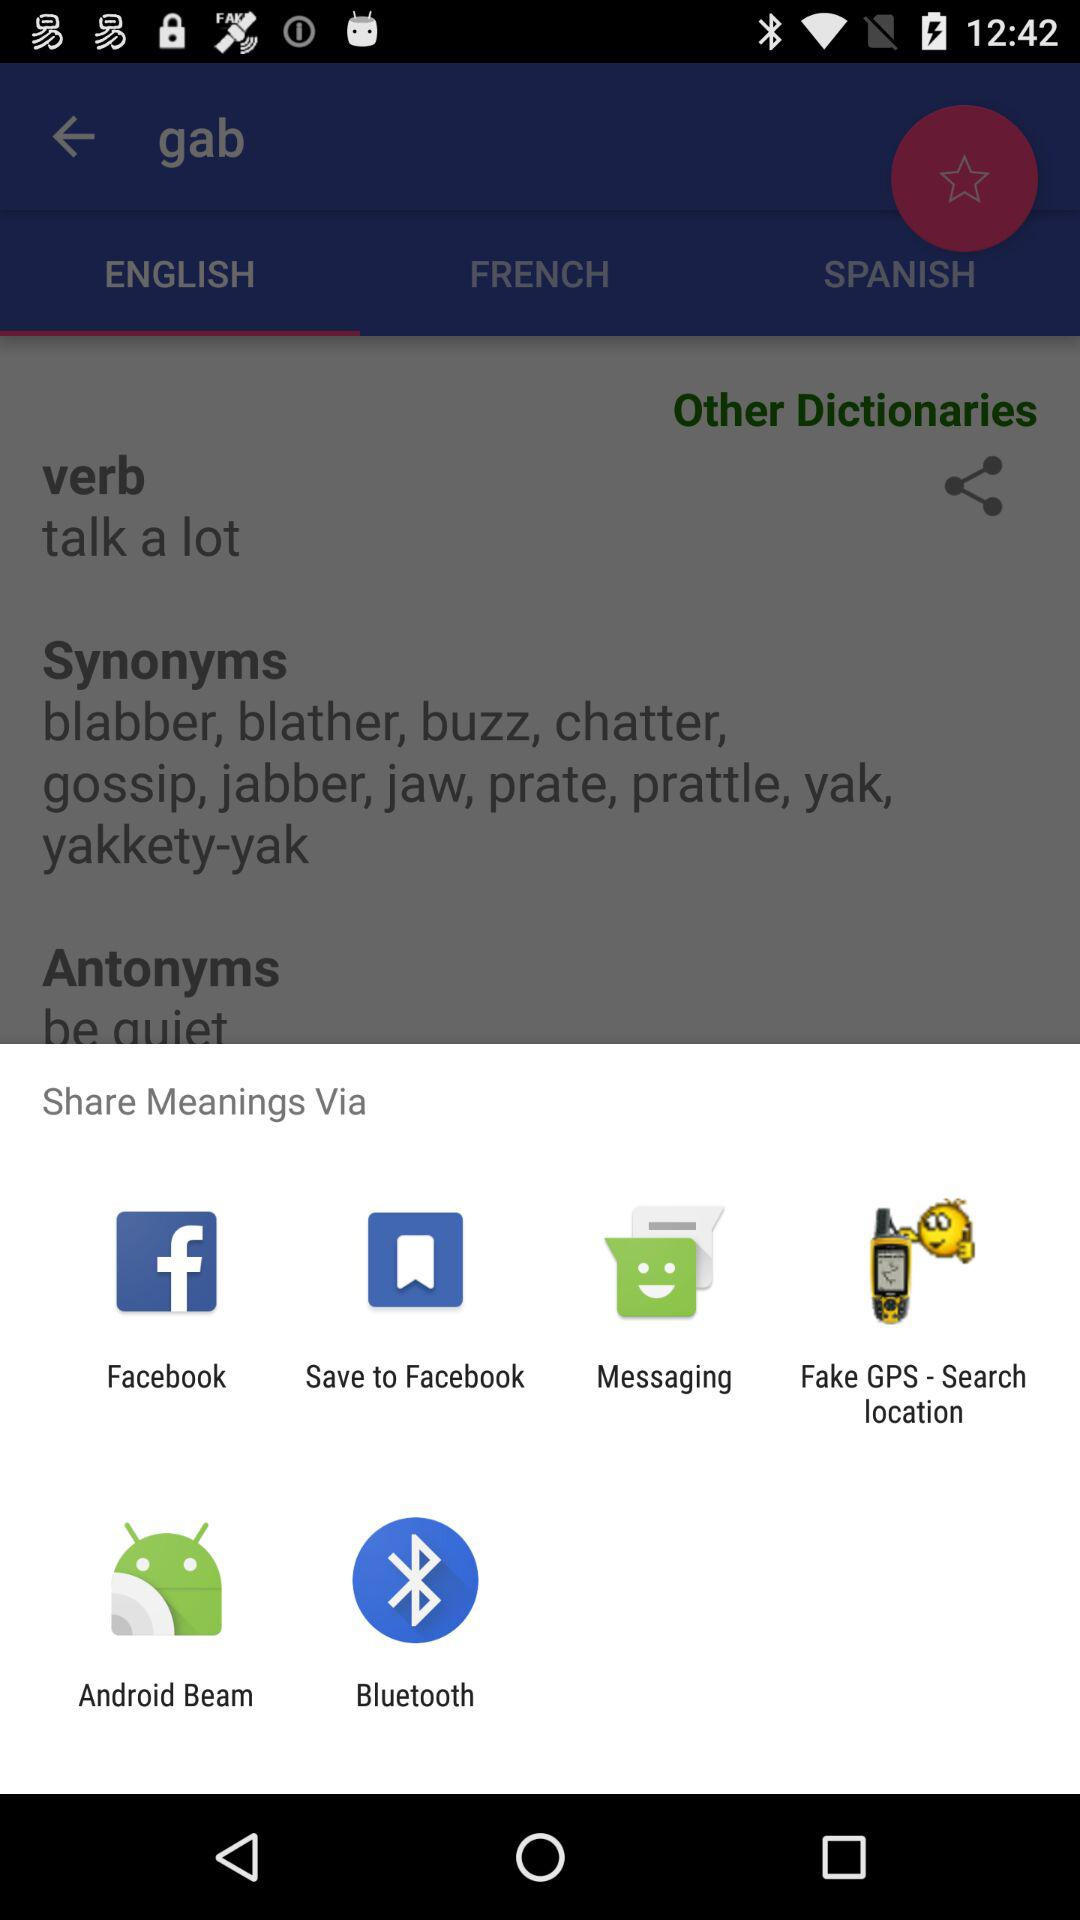What applications can I use to share the "Meanings"? The applications are "Facebook", "Save to Facebook", "Messaging", "Fake GPS - Search location", "Android Beam" and "Bluetooth". 